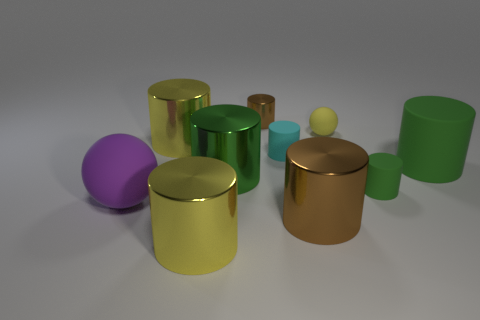Do the tiny metal cylinder and the metallic cylinder to the right of the small brown metallic cylinder have the same color?
Give a very brief answer. Yes. How many other things are the same color as the tiny metal thing?
Offer a very short reply. 1. What is the material of the small cylinder that is the same color as the large matte cylinder?
Offer a terse response. Rubber. Are there any brown cylinders that have the same size as the green shiny object?
Make the answer very short. Yes. There is a tiny matte object that is to the right of the small yellow matte ball; is its color the same as the large matte cylinder?
Provide a short and direct response. Yes. There is a metallic cylinder that is both right of the big green metallic object and in front of the small brown thing; what is its color?
Your answer should be very brief. Brown. There is a purple matte thing that is the same size as the green metallic cylinder; what is its shape?
Keep it short and to the point. Sphere. Are there any purple matte objects of the same shape as the small green rubber thing?
Provide a succinct answer. No. Is the size of the shiny thing behind the yellow sphere the same as the big purple thing?
Provide a succinct answer. No. How big is the yellow object that is behind the big purple rubber sphere and in front of the tiny ball?
Offer a very short reply. Large. 